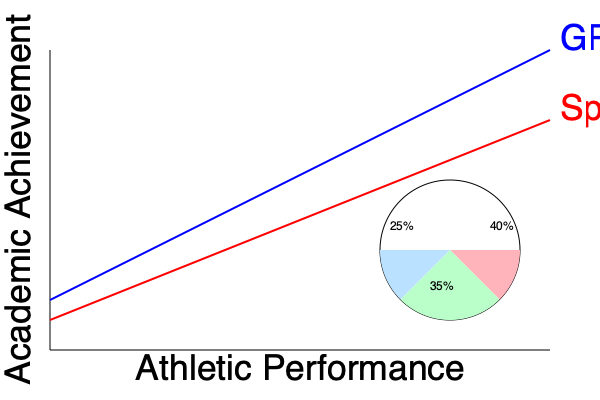Based on the line graph and pie chart provided, what conclusion can be drawn about the relationship between athletic performance and academic achievement in college sports, and how does this relate to the distribution of student-athletes across different performance categories? To answer this question, let's analyze the graph step-by-step:

1. Line Graph Analysis:
   a. The blue line represents GPA (academic achievement).
   b. The red line represents sports performance (athletic performance).
   c. As we move from left to right, both lines show an upward trend.
   d. The blue line (GPA) has a steeper slope compared to the red line (sports performance).

2. Correlation between Athletic and Academic Performance:
   - The upward trend of both lines indicates a positive correlation between athletic performance and academic achievement.
   - As athletic performance improves, academic achievement also tends to improve, but at a faster rate (steeper slope of the blue line).

3. Pie Chart Analysis:
   The pie chart likely represents the distribution of student-athletes across different performance categories:
   - 40% (largest slice): High performers in both academics and athletics
   - 35% (middle slice): Average performers
   - 25% (smallest slice): Lower performers

4. Connecting the Line Graph and Pie Chart:
   - The positive correlation in the line graph supports the largest slice (40%) in the pie chart, representing high performers in both areas.
   - The smaller slices (35% and 25%) may represent the student-athletes who fall at different points along the performance curves in the line graph.

5. Relevance to College Sports:
   - This data suggests that success in college sports is not mutually exclusive with academic achievement.
   - It supports the idea that student-athletes can excel in both areas, with a significant portion (40%) achieving high performance in both academics and athletics.
Answer: Positive correlation between athletic and academic performance, with 40% of student-athletes excelling in both areas. 